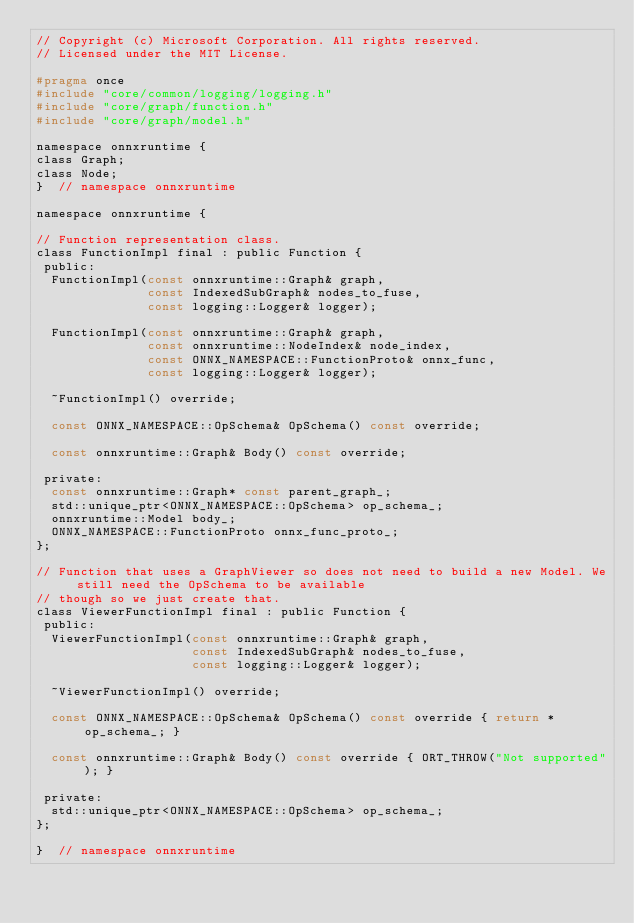<code> <loc_0><loc_0><loc_500><loc_500><_C_>// Copyright (c) Microsoft Corporation. All rights reserved.
// Licensed under the MIT License.

#pragma once
#include "core/common/logging/logging.h"
#include "core/graph/function.h"
#include "core/graph/model.h"

namespace onnxruntime {
class Graph;
class Node;
}  // namespace onnxruntime

namespace onnxruntime {

// Function representation class.
class FunctionImpl final : public Function {
 public:
  FunctionImpl(const onnxruntime::Graph& graph,
               const IndexedSubGraph& nodes_to_fuse,
               const logging::Logger& logger);

  FunctionImpl(const onnxruntime::Graph& graph,
               const onnxruntime::NodeIndex& node_index,
               const ONNX_NAMESPACE::FunctionProto& onnx_func,
               const logging::Logger& logger);

  ~FunctionImpl() override;

  const ONNX_NAMESPACE::OpSchema& OpSchema() const override;

  const onnxruntime::Graph& Body() const override;

 private:
  const onnxruntime::Graph* const parent_graph_;
  std::unique_ptr<ONNX_NAMESPACE::OpSchema> op_schema_;
  onnxruntime::Model body_;
  ONNX_NAMESPACE::FunctionProto onnx_func_proto_;
};

// Function that uses a GraphViewer so does not need to build a new Model. We still need the OpSchema to be available
// though so we just create that.
class ViewerFunctionImpl final : public Function {
 public:
  ViewerFunctionImpl(const onnxruntime::Graph& graph,
                     const IndexedSubGraph& nodes_to_fuse,
                     const logging::Logger& logger);

  ~ViewerFunctionImpl() override;

  const ONNX_NAMESPACE::OpSchema& OpSchema() const override { return *op_schema_; }

  const onnxruntime::Graph& Body() const override { ORT_THROW("Not supported"); }

 private:
  std::unique_ptr<ONNX_NAMESPACE::OpSchema> op_schema_;
};

}  // namespace onnxruntime
</code> 